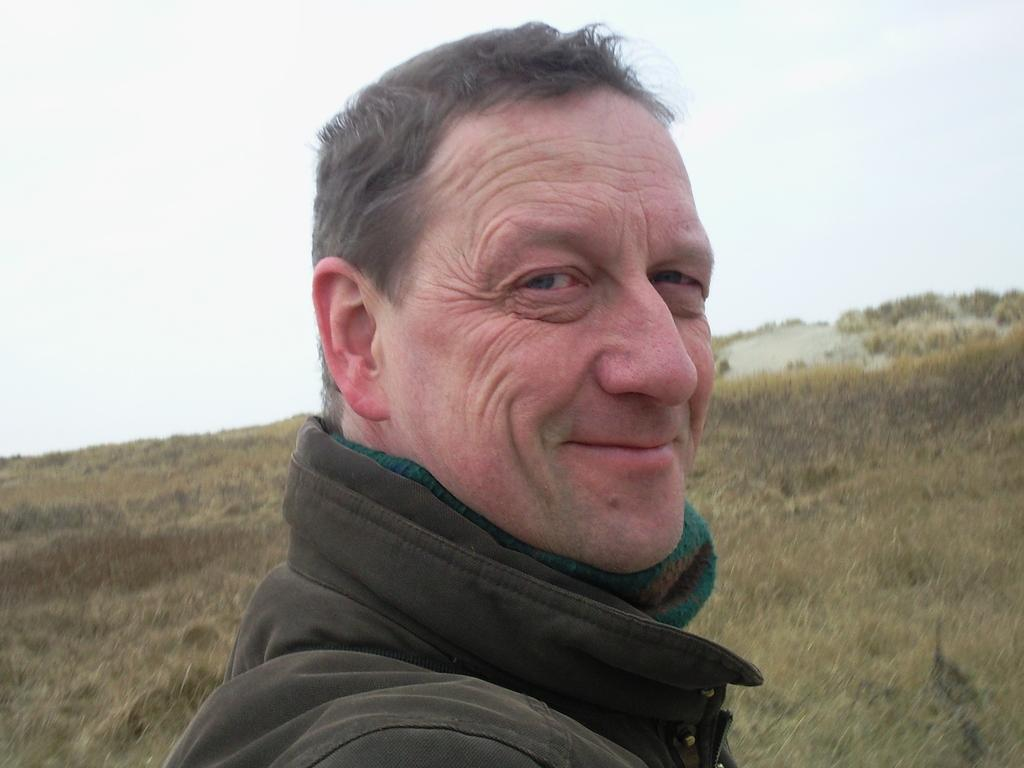What is present in the image? There is a man in the image. What is the man's facial expression? The man is smiling. What type of natural environment is visible in the image? There is grass visible in the image. What is visible in the background of the image? The sky is visible in the background of the image. What type of lead can be seen being carried by the goose in the image? There is no goose or lead present in the image. What impulse might have caused the man to smile in the image? It is impossible to determine the man's impulse or reason for smiling from the image alone. 